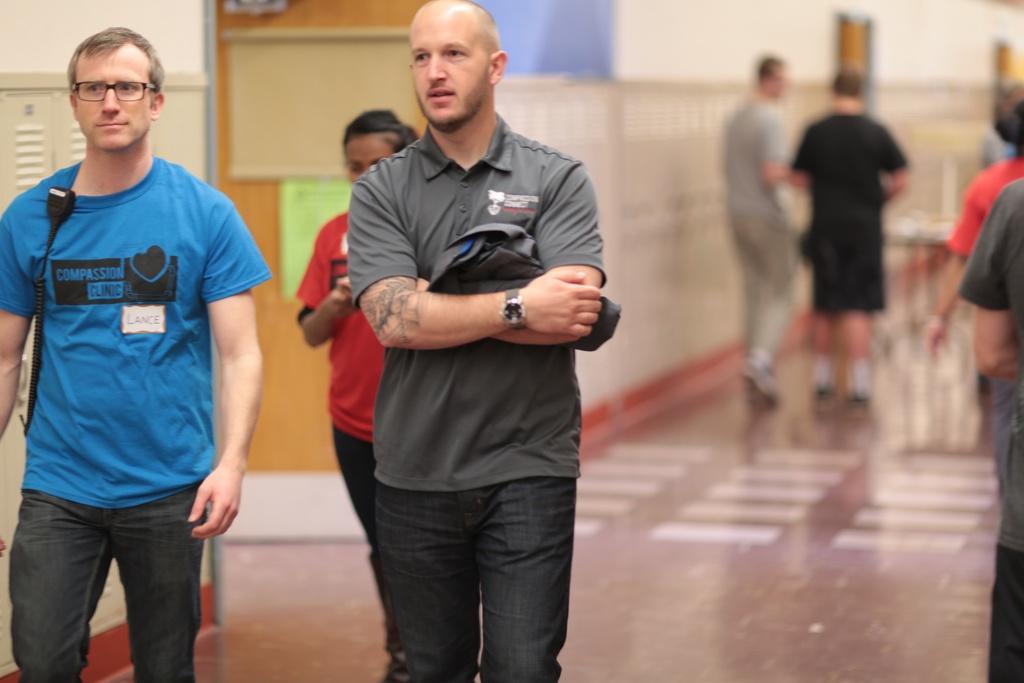Describe this image in one or two sentences. In this picture we can see some persons are there. In the background of the image we can see door, boards, wall, rods. At the bottom of the image we can see the floor. 